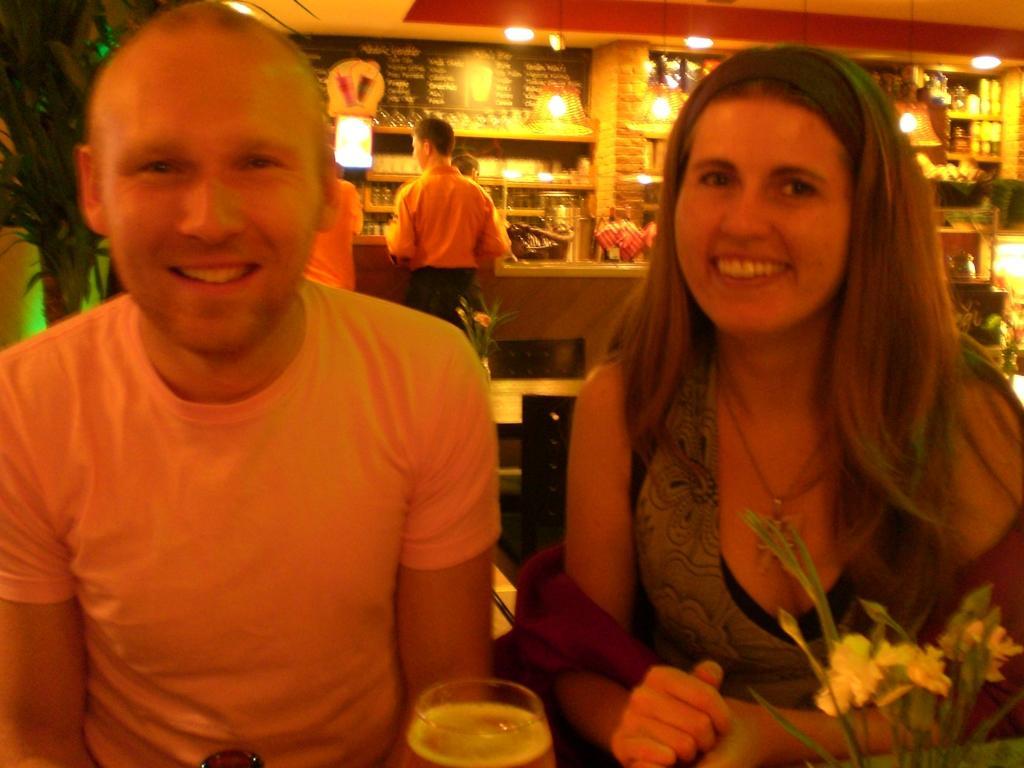In one or two sentences, can you explain what this image depicts? In this image I can see two people sitting in-front of the table. These people are wearing the different color dresses. I can see the glass and flower vase. To the left I can see the plant. In the background I can see few people standing at the stall. I can see there are boards and many objects in the stall. I can see the lights in the top. 